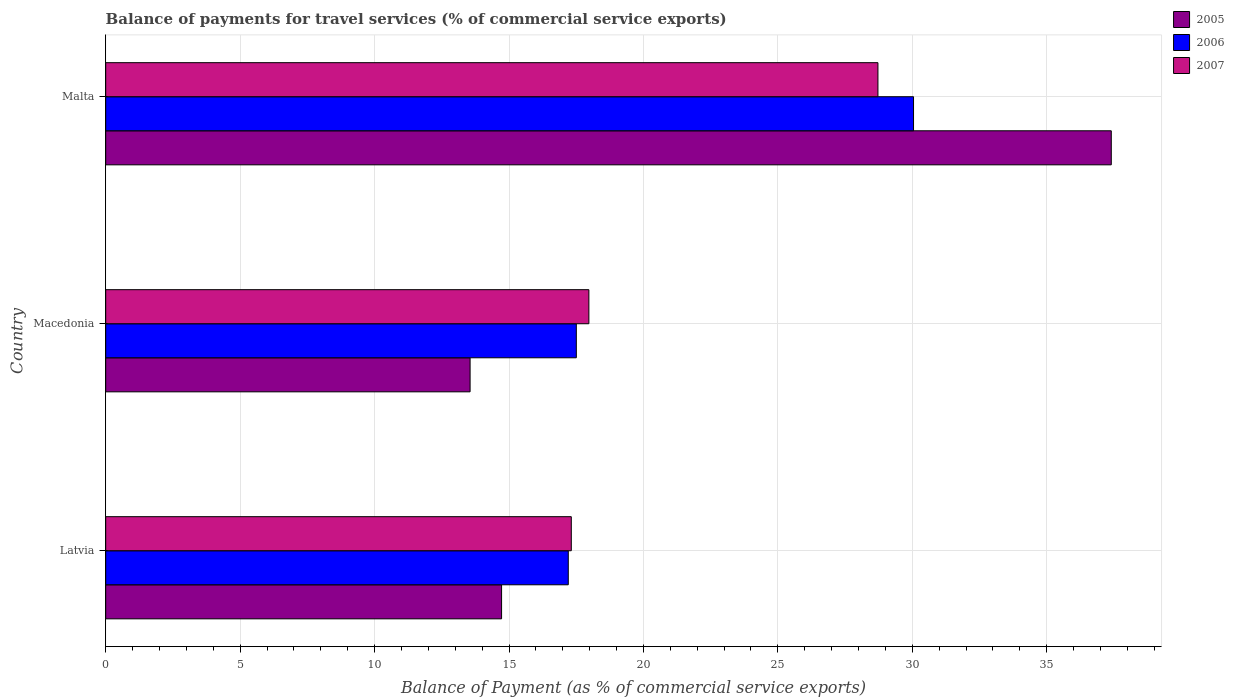How many different coloured bars are there?
Make the answer very short. 3. Are the number of bars on each tick of the Y-axis equal?
Provide a short and direct response. Yes. How many bars are there on the 2nd tick from the top?
Give a very brief answer. 3. How many bars are there on the 2nd tick from the bottom?
Provide a succinct answer. 3. What is the label of the 1st group of bars from the top?
Your response must be concise. Malta. What is the balance of payments for travel services in 2006 in Macedonia?
Offer a very short reply. 17.5. Across all countries, what is the maximum balance of payments for travel services in 2006?
Your answer should be very brief. 30.05. Across all countries, what is the minimum balance of payments for travel services in 2005?
Keep it short and to the point. 13.55. In which country was the balance of payments for travel services in 2006 maximum?
Provide a short and direct response. Malta. In which country was the balance of payments for travel services in 2006 minimum?
Your response must be concise. Latvia. What is the total balance of payments for travel services in 2006 in the graph?
Your answer should be compact. 64.75. What is the difference between the balance of payments for travel services in 2006 in Latvia and that in Malta?
Offer a very short reply. -12.84. What is the difference between the balance of payments for travel services in 2005 in Macedonia and the balance of payments for travel services in 2006 in Latvia?
Offer a very short reply. -3.65. What is the average balance of payments for travel services in 2007 per country?
Ensure brevity in your answer.  21.34. What is the difference between the balance of payments for travel services in 2007 and balance of payments for travel services in 2006 in Macedonia?
Your answer should be compact. 0.47. What is the ratio of the balance of payments for travel services in 2006 in Latvia to that in Malta?
Your answer should be compact. 0.57. Is the difference between the balance of payments for travel services in 2007 in Latvia and Macedonia greater than the difference between the balance of payments for travel services in 2006 in Latvia and Macedonia?
Offer a very short reply. No. What is the difference between the highest and the second highest balance of payments for travel services in 2006?
Provide a short and direct response. 12.54. What is the difference between the highest and the lowest balance of payments for travel services in 2005?
Keep it short and to the point. 23.85. What does the 1st bar from the bottom in Latvia represents?
Offer a very short reply. 2005. How many bars are there?
Your response must be concise. 9. Are all the bars in the graph horizontal?
Provide a short and direct response. Yes. What is the difference between two consecutive major ticks on the X-axis?
Make the answer very short. 5. Does the graph contain any zero values?
Make the answer very short. No. Where does the legend appear in the graph?
Offer a very short reply. Top right. How many legend labels are there?
Your answer should be compact. 3. What is the title of the graph?
Make the answer very short. Balance of payments for travel services (% of commercial service exports). Does "2002" appear as one of the legend labels in the graph?
Make the answer very short. No. What is the label or title of the X-axis?
Offer a very short reply. Balance of Payment (as % of commercial service exports). What is the Balance of Payment (as % of commercial service exports) in 2005 in Latvia?
Give a very brief answer. 14.72. What is the Balance of Payment (as % of commercial service exports) of 2006 in Latvia?
Offer a terse response. 17.2. What is the Balance of Payment (as % of commercial service exports) in 2007 in Latvia?
Provide a short and direct response. 17.32. What is the Balance of Payment (as % of commercial service exports) in 2005 in Macedonia?
Your response must be concise. 13.55. What is the Balance of Payment (as % of commercial service exports) of 2006 in Macedonia?
Keep it short and to the point. 17.5. What is the Balance of Payment (as % of commercial service exports) of 2007 in Macedonia?
Keep it short and to the point. 17.97. What is the Balance of Payment (as % of commercial service exports) in 2005 in Malta?
Your response must be concise. 37.4. What is the Balance of Payment (as % of commercial service exports) in 2006 in Malta?
Offer a very short reply. 30.05. What is the Balance of Payment (as % of commercial service exports) of 2007 in Malta?
Give a very brief answer. 28.72. Across all countries, what is the maximum Balance of Payment (as % of commercial service exports) of 2005?
Give a very brief answer. 37.4. Across all countries, what is the maximum Balance of Payment (as % of commercial service exports) in 2006?
Your response must be concise. 30.05. Across all countries, what is the maximum Balance of Payment (as % of commercial service exports) of 2007?
Offer a very short reply. 28.72. Across all countries, what is the minimum Balance of Payment (as % of commercial service exports) of 2005?
Offer a very short reply. 13.55. Across all countries, what is the minimum Balance of Payment (as % of commercial service exports) in 2006?
Provide a succinct answer. 17.2. Across all countries, what is the minimum Balance of Payment (as % of commercial service exports) of 2007?
Keep it short and to the point. 17.32. What is the total Balance of Payment (as % of commercial service exports) of 2005 in the graph?
Provide a short and direct response. 65.68. What is the total Balance of Payment (as % of commercial service exports) in 2006 in the graph?
Provide a short and direct response. 64.75. What is the total Balance of Payment (as % of commercial service exports) in 2007 in the graph?
Offer a terse response. 64.01. What is the difference between the Balance of Payment (as % of commercial service exports) of 2005 in Latvia and that in Macedonia?
Keep it short and to the point. 1.17. What is the difference between the Balance of Payment (as % of commercial service exports) in 2006 in Latvia and that in Macedonia?
Offer a terse response. -0.3. What is the difference between the Balance of Payment (as % of commercial service exports) of 2007 in Latvia and that in Macedonia?
Keep it short and to the point. -0.65. What is the difference between the Balance of Payment (as % of commercial service exports) of 2005 in Latvia and that in Malta?
Provide a short and direct response. -22.68. What is the difference between the Balance of Payment (as % of commercial service exports) of 2006 in Latvia and that in Malta?
Your response must be concise. -12.84. What is the difference between the Balance of Payment (as % of commercial service exports) in 2007 in Latvia and that in Malta?
Keep it short and to the point. -11.4. What is the difference between the Balance of Payment (as % of commercial service exports) in 2005 in Macedonia and that in Malta?
Offer a very short reply. -23.85. What is the difference between the Balance of Payment (as % of commercial service exports) in 2006 in Macedonia and that in Malta?
Your response must be concise. -12.54. What is the difference between the Balance of Payment (as % of commercial service exports) in 2007 in Macedonia and that in Malta?
Ensure brevity in your answer.  -10.75. What is the difference between the Balance of Payment (as % of commercial service exports) of 2005 in Latvia and the Balance of Payment (as % of commercial service exports) of 2006 in Macedonia?
Give a very brief answer. -2.78. What is the difference between the Balance of Payment (as % of commercial service exports) of 2005 in Latvia and the Balance of Payment (as % of commercial service exports) of 2007 in Macedonia?
Ensure brevity in your answer.  -3.25. What is the difference between the Balance of Payment (as % of commercial service exports) in 2006 in Latvia and the Balance of Payment (as % of commercial service exports) in 2007 in Macedonia?
Give a very brief answer. -0.77. What is the difference between the Balance of Payment (as % of commercial service exports) of 2005 in Latvia and the Balance of Payment (as % of commercial service exports) of 2006 in Malta?
Keep it short and to the point. -15.32. What is the difference between the Balance of Payment (as % of commercial service exports) in 2005 in Latvia and the Balance of Payment (as % of commercial service exports) in 2007 in Malta?
Provide a short and direct response. -14. What is the difference between the Balance of Payment (as % of commercial service exports) of 2006 in Latvia and the Balance of Payment (as % of commercial service exports) of 2007 in Malta?
Your response must be concise. -11.52. What is the difference between the Balance of Payment (as % of commercial service exports) of 2005 in Macedonia and the Balance of Payment (as % of commercial service exports) of 2006 in Malta?
Provide a short and direct response. -16.49. What is the difference between the Balance of Payment (as % of commercial service exports) in 2005 in Macedonia and the Balance of Payment (as % of commercial service exports) in 2007 in Malta?
Keep it short and to the point. -15.17. What is the difference between the Balance of Payment (as % of commercial service exports) in 2006 in Macedonia and the Balance of Payment (as % of commercial service exports) in 2007 in Malta?
Provide a succinct answer. -11.22. What is the average Balance of Payment (as % of commercial service exports) of 2005 per country?
Your response must be concise. 21.89. What is the average Balance of Payment (as % of commercial service exports) of 2006 per country?
Your response must be concise. 21.58. What is the average Balance of Payment (as % of commercial service exports) of 2007 per country?
Provide a short and direct response. 21.34. What is the difference between the Balance of Payment (as % of commercial service exports) of 2005 and Balance of Payment (as % of commercial service exports) of 2006 in Latvia?
Provide a short and direct response. -2.48. What is the difference between the Balance of Payment (as % of commercial service exports) in 2005 and Balance of Payment (as % of commercial service exports) in 2007 in Latvia?
Provide a short and direct response. -2.59. What is the difference between the Balance of Payment (as % of commercial service exports) in 2006 and Balance of Payment (as % of commercial service exports) in 2007 in Latvia?
Keep it short and to the point. -0.11. What is the difference between the Balance of Payment (as % of commercial service exports) of 2005 and Balance of Payment (as % of commercial service exports) of 2006 in Macedonia?
Give a very brief answer. -3.95. What is the difference between the Balance of Payment (as % of commercial service exports) of 2005 and Balance of Payment (as % of commercial service exports) of 2007 in Macedonia?
Ensure brevity in your answer.  -4.42. What is the difference between the Balance of Payment (as % of commercial service exports) in 2006 and Balance of Payment (as % of commercial service exports) in 2007 in Macedonia?
Your answer should be very brief. -0.47. What is the difference between the Balance of Payment (as % of commercial service exports) of 2005 and Balance of Payment (as % of commercial service exports) of 2006 in Malta?
Ensure brevity in your answer.  7.35. What is the difference between the Balance of Payment (as % of commercial service exports) of 2005 and Balance of Payment (as % of commercial service exports) of 2007 in Malta?
Your answer should be very brief. 8.68. What is the difference between the Balance of Payment (as % of commercial service exports) in 2006 and Balance of Payment (as % of commercial service exports) in 2007 in Malta?
Make the answer very short. 1.32. What is the ratio of the Balance of Payment (as % of commercial service exports) in 2005 in Latvia to that in Macedonia?
Provide a short and direct response. 1.09. What is the ratio of the Balance of Payment (as % of commercial service exports) of 2006 in Latvia to that in Macedonia?
Provide a short and direct response. 0.98. What is the ratio of the Balance of Payment (as % of commercial service exports) in 2007 in Latvia to that in Macedonia?
Provide a short and direct response. 0.96. What is the ratio of the Balance of Payment (as % of commercial service exports) of 2005 in Latvia to that in Malta?
Give a very brief answer. 0.39. What is the ratio of the Balance of Payment (as % of commercial service exports) in 2006 in Latvia to that in Malta?
Offer a terse response. 0.57. What is the ratio of the Balance of Payment (as % of commercial service exports) in 2007 in Latvia to that in Malta?
Your answer should be compact. 0.6. What is the ratio of the Balance of Payment (as % of commercial service exports) in 2005 in Macedonia to that in Malta?
Make the answer very short. 0.36. What is the ratio of the Balance of Payment (as % of commercial service exports) of 2006 in Macedonia to that in Malta?
Keep it short and to the point. 0.58. What is the ratio of the Balance of Payment (as % of commercial service exports) of 2007 in Macedonia to that in Malta?
Your answer should be very brief. 0.63. What is the difference between the highest and the second highest Balance of Payment (as % of commercial service exports) in 2005?
Offer a terse response. 22.68. What is the difference between the highest and the second highest Balance of Payment (as % of commercial service exports) of 2006?
Your response must be concise. 12.54. What is the difference between the highest and the second highest Balance of Payment (as % of commercial service exports) in 2007?
Your response must be concise. 10.75. What is the difference between the highest and the lowest Balance of Payment (as % of commercial service exports) of 2005?
Offer a very short reply. 23.85. What is the difference between the highest and the lowest Balance of Payment (as % of commercial service exports) of 2006?
Provide a short and direct response. 12.84. What is the difference between the highest and the lowest Balance of Payment (as % of commercial service exports) in 2007?
Make the answer very short. 11.4. 